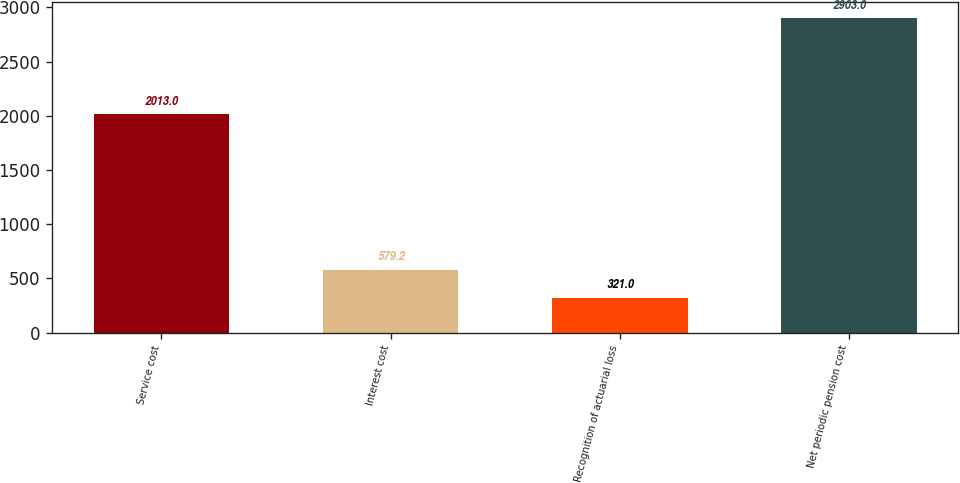<chart> <loc_0><loc_0><loc_500><loc_500><bar_chart><fcel>Service cost<fcel>Interest cost<fcel>Recognition of actuarial loss<fcel>Net periodic pension cost<nl><fcel>2013<fcel>579.2<fcel>321<fcel>2903<nl></chart> 